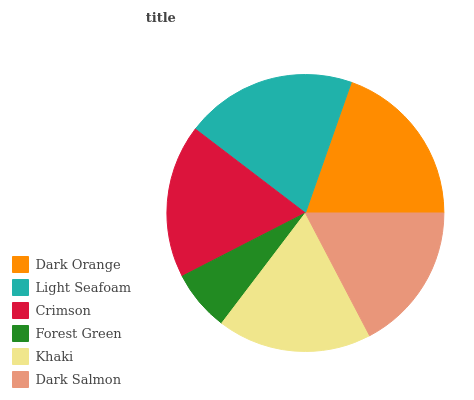Is Forest Green the minimum?
Answer yes or no. Yes. Is Light Seafoam the maximum?
Answer yes or no. Yes. Is Crimson the minimum?
Answer yes or no. No. Is Crimson the maximum?
Answer yes or no. No. Is Light Seafoam greater than Crimson?
Answer yes or no. Yes. Is Crimson less than Light Seafoam?
Answer yes or no. Yes. Is Crimson greater than Light Seafoam?
Answer yes or no. No. Is Light Seafoam less than Crimson?
Answer yes or no. No. Is Khaki the high median?
Answer yes or no. Yes. Is Crimson the low median?
Answer yes or no. Yes. Is Dark Salmon the high median?
Answer yes or no. No. Is Dark Salmon the low median?
Answer yes or no. No. 